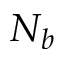Convert formula to latex. <formula><loc_0><loc_0><loc_500><loc_500>N _ { b }</formula> 